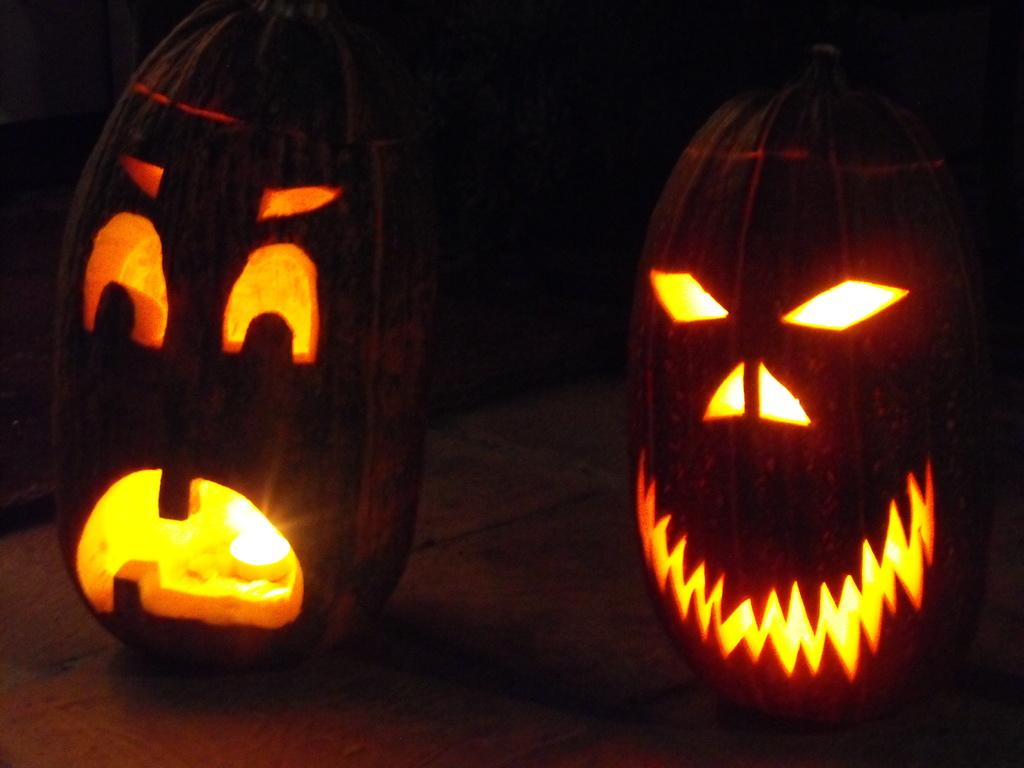How many pumpkins are in the image? There are two pumpkins in the image. What can be observed about the background of the image? The background of the image is dark. Is there any source of light visible in the image? Yes, there is a light visible in the image. What size wrench is being used to carve the pumpkins in the image? There is no wrench present in the image, and the pumpkins are not being carved. 